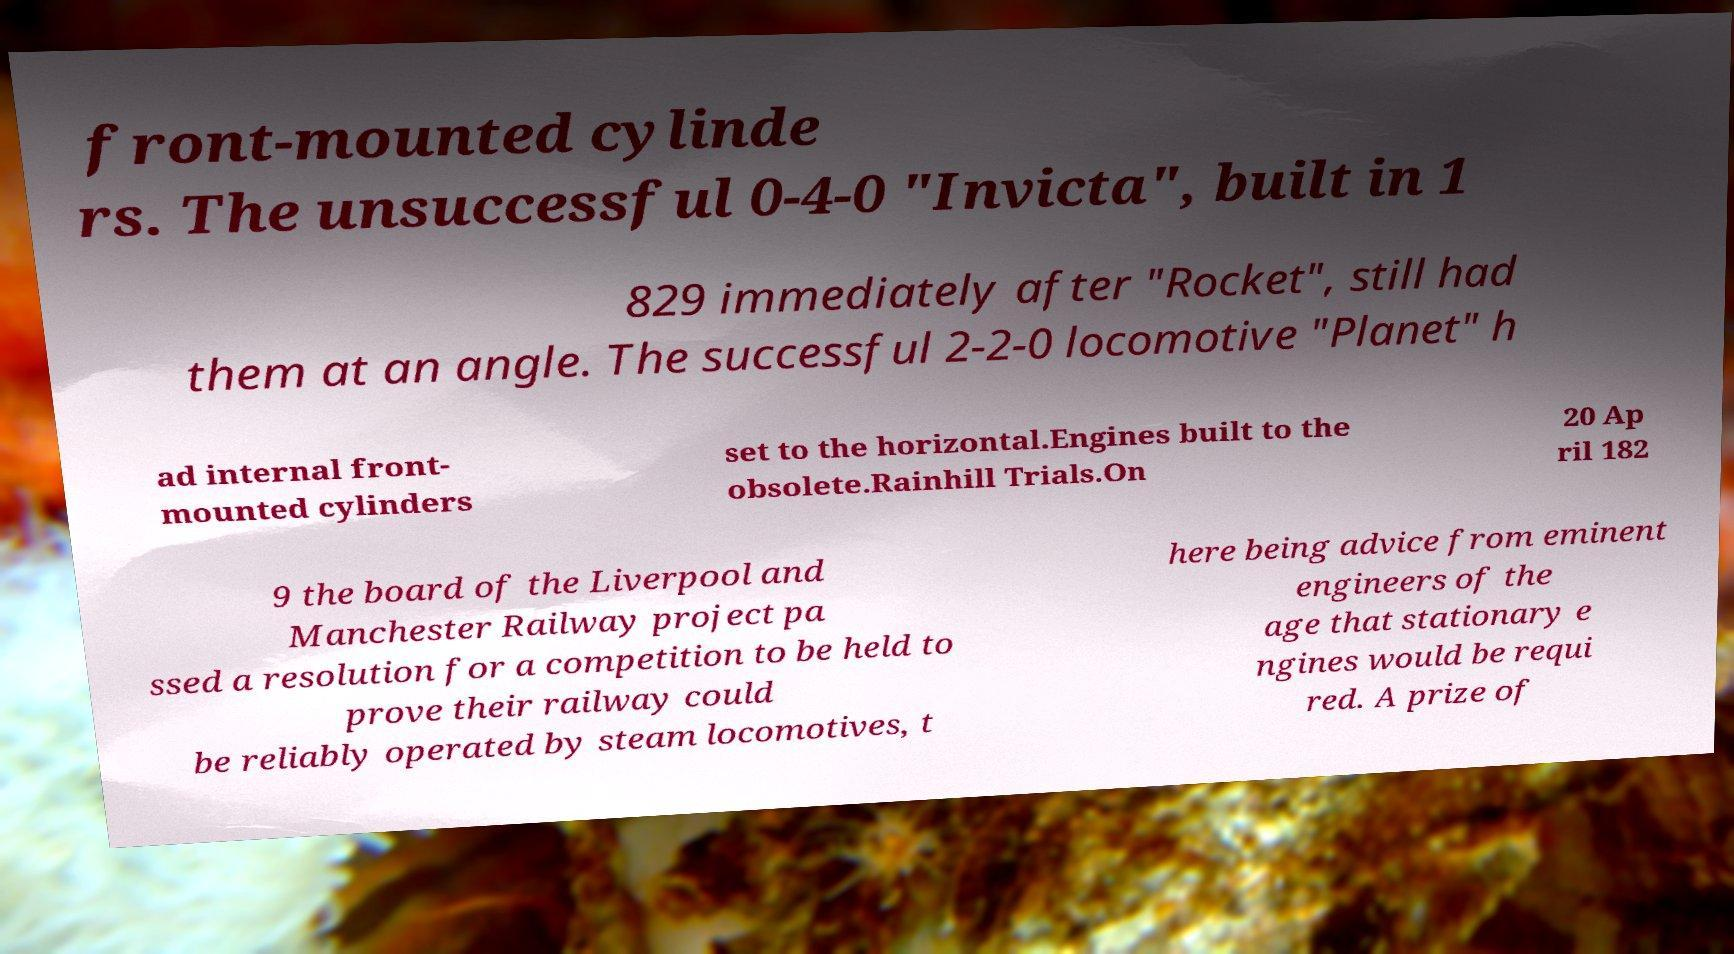For documentation purposes, I need the text within this image transcribed. Could you provide that? front-mounted cylinde rs. The unsuccessful 0-4-0 "Invicta", built in 1 829 immediately after "Rocket", still had them at an angle. The successful 2-2-0 locomotive "Planet" h ad internal front- mounted cylinders set to the horizontal.Engines built to the obsolete.Rainhill Trials.On 20 Ap ril 182 9 the board of the Liverpool and Manchester Railway project pa ssed a resolution for a competition to be held to prove their railway could be reliably operated by steam locomotives, t here being advice from eminent engineers of the age that stationary e ngines would be requi red. A prize of 